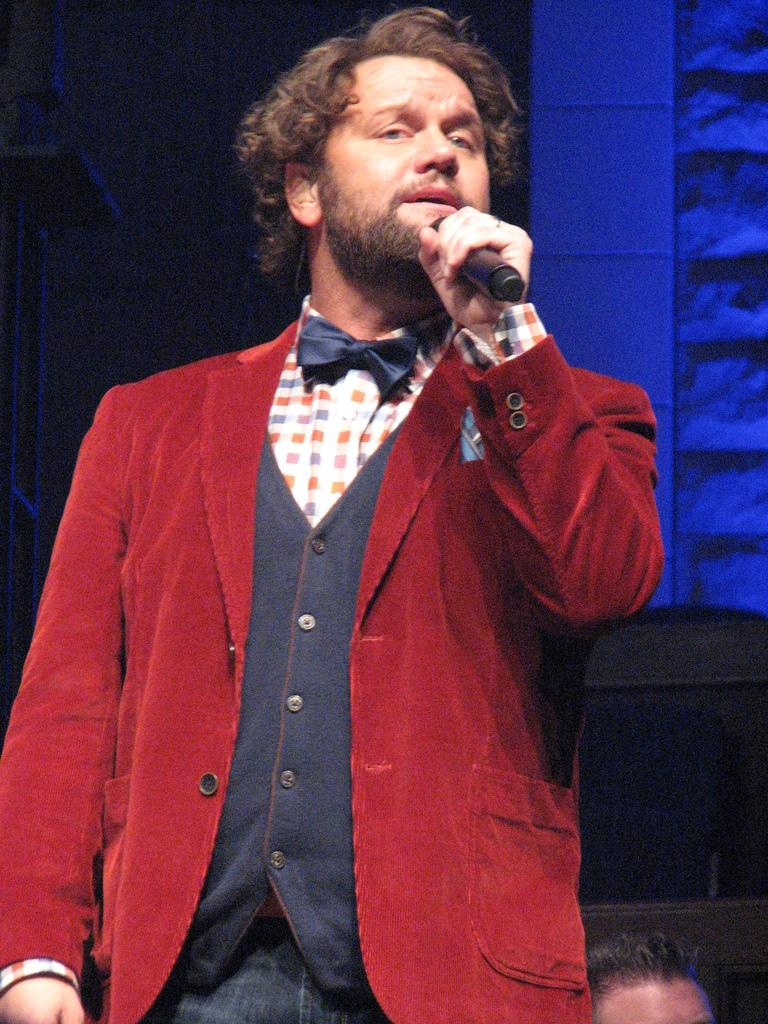What is happening in the room in the image? There is a man in the room, and he is singing. What is the man wearing in the image? The man is wearing a red blazer. What object is the man holding in the image? The man is holding a microphone. What type of gate can be seen in the image? There is no gate present in the image; it features a man singing while wearing a red blazer and holding a microphone. 